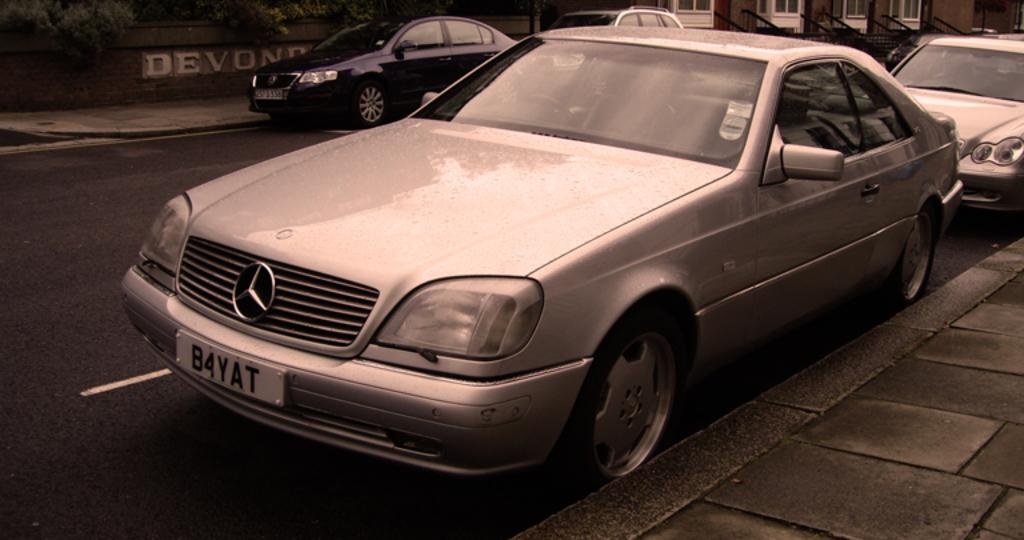What does the license plate say?
Your answer should be very brief. B4yat. What text is visible across the street?
Keep it short and to the point. Devond. 